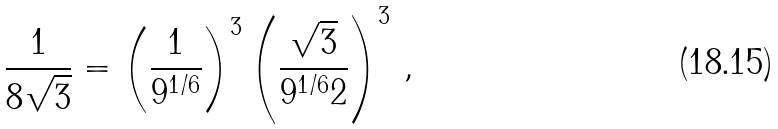Convert formula to latex. <formula><loc_0><loc_0><loc_500><loc_500>\frac { 1 } { 8 \sqrt { 3 } } = \left ( \frac { 1 } { 9 ^ { 1 / 6 } } \right ) ^ { 3 } \left ( \frac { \sqrt { 3 } } { 9 ^ { 1 / 6 } 2 } \right ) ^ { 3 } \, ,</formula> 